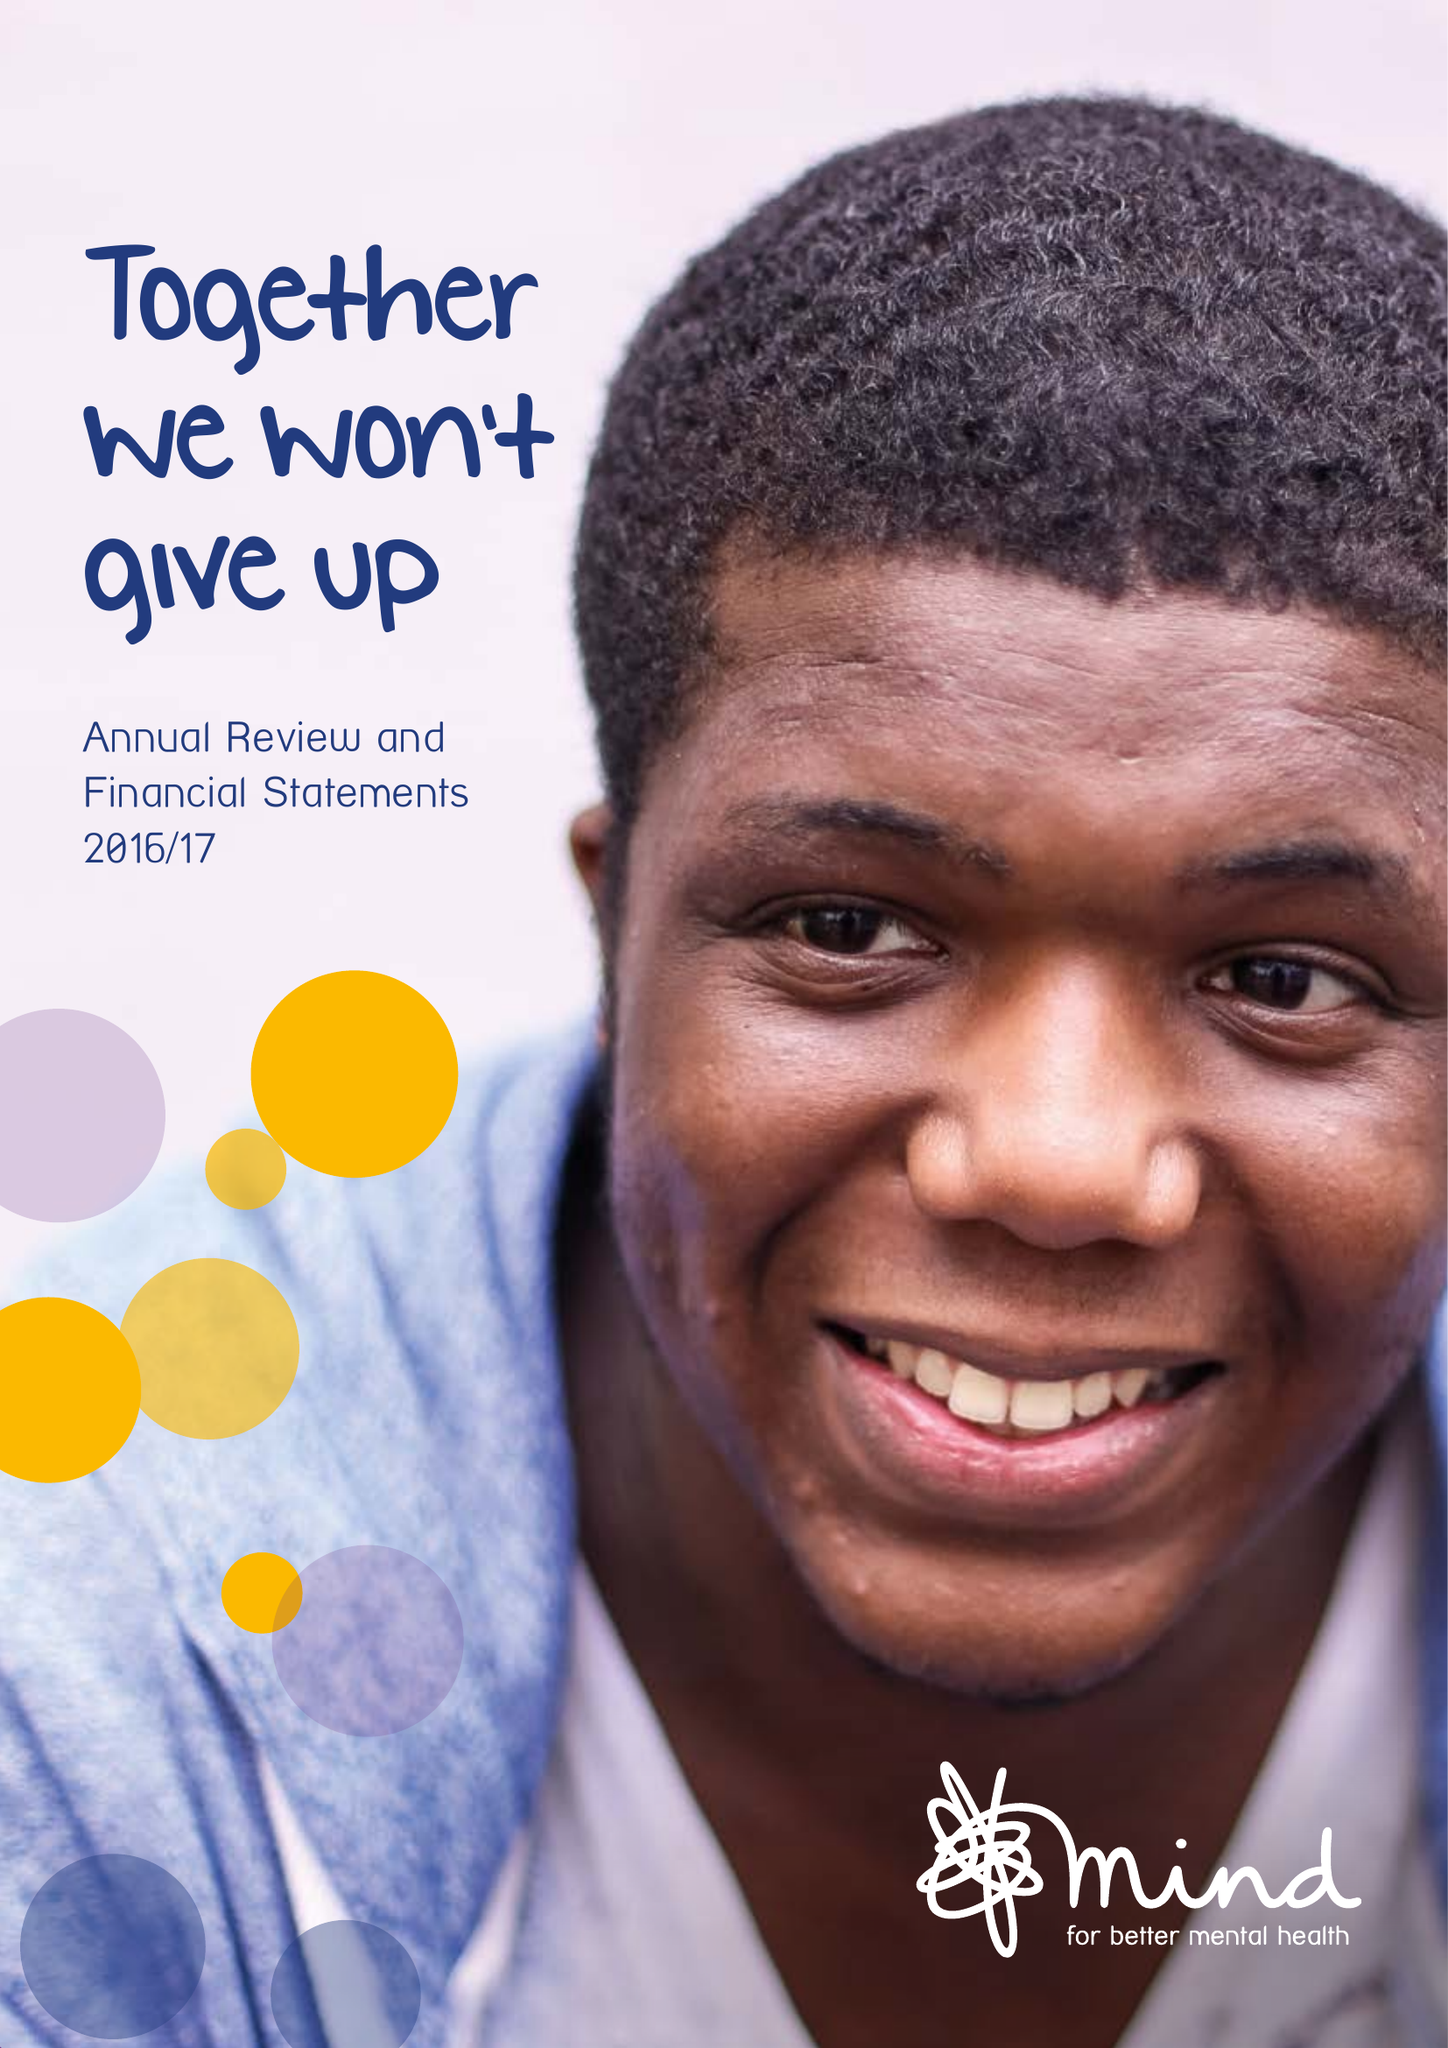What is the value for the address__postcode?
Answer the question using a single word or phrase. E15 4BQ 